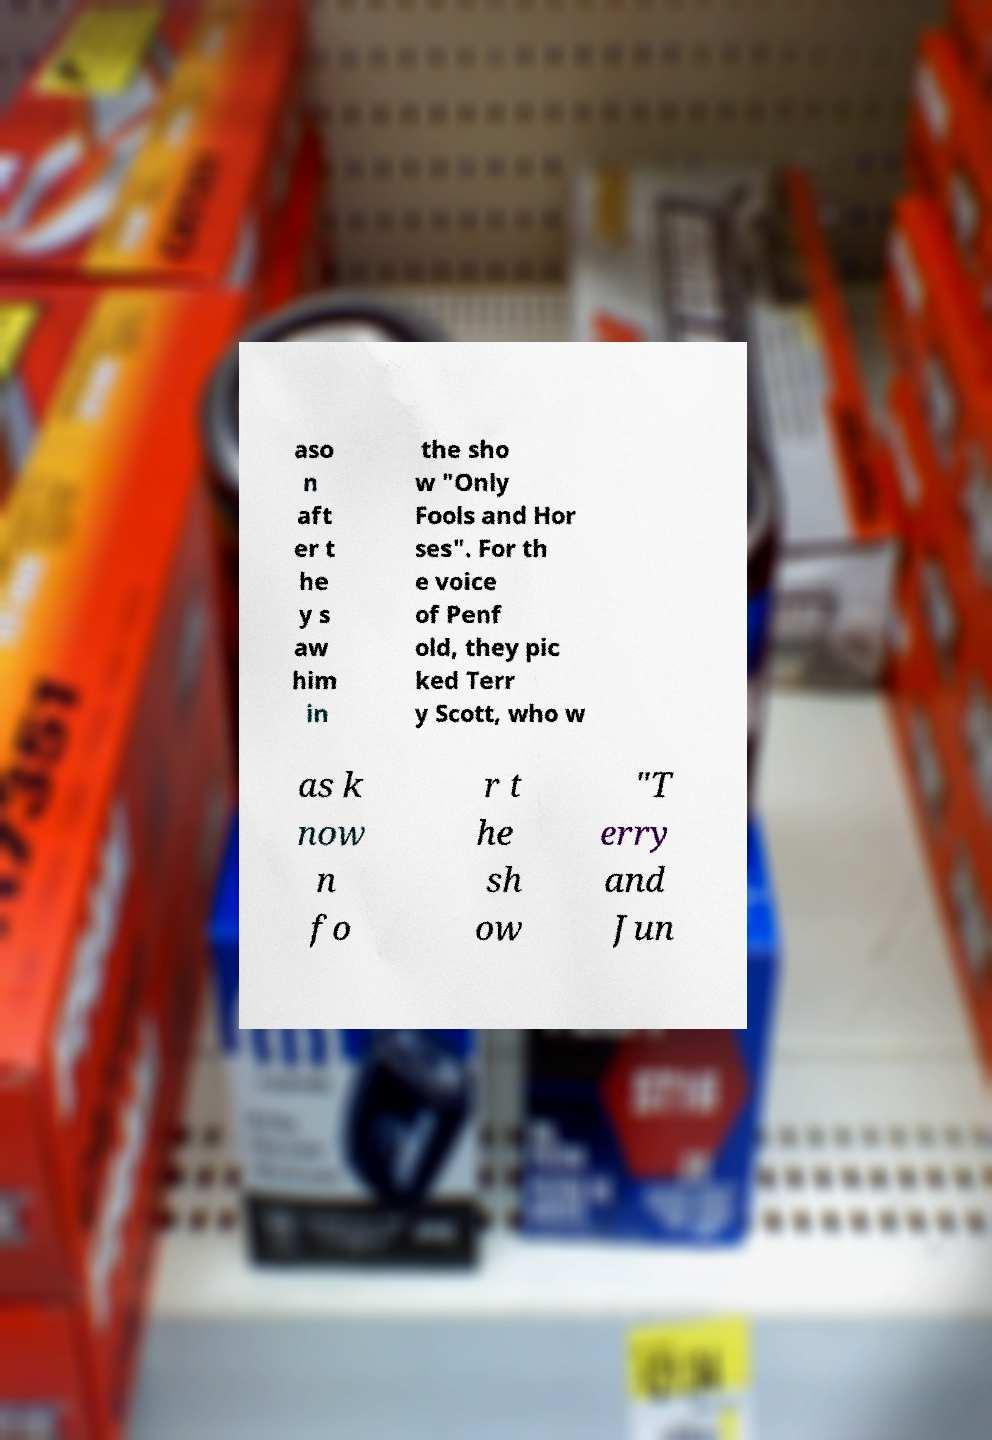Can you accurately transcribe the text from the provided image for me? aso n aft er t he y s aw him in the sho w "Only Fools and Hor ses". For th e voice of Penf old, they pic ked Terr y Scott, who w as k now n fo r t he sh ow "T erry and Jun 